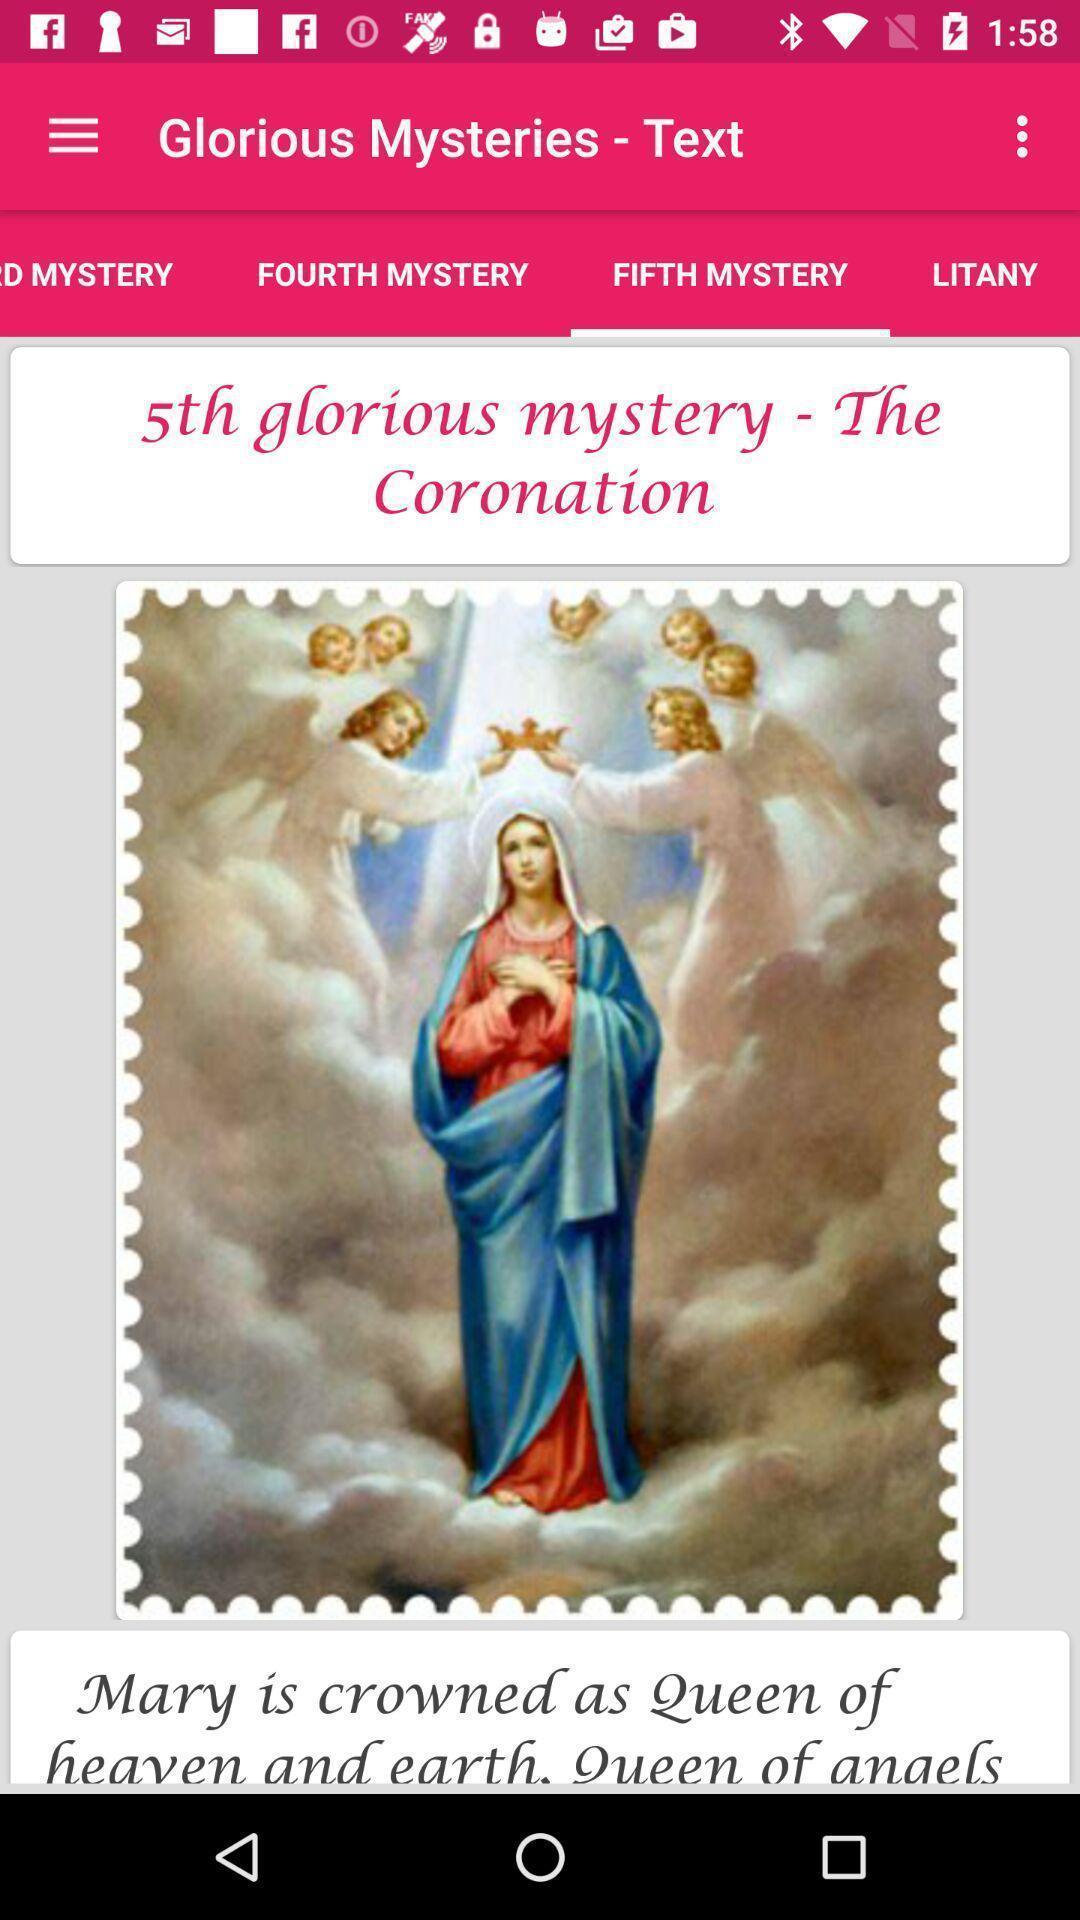Describe this image in words. Page showing the fifth mystery tab. 